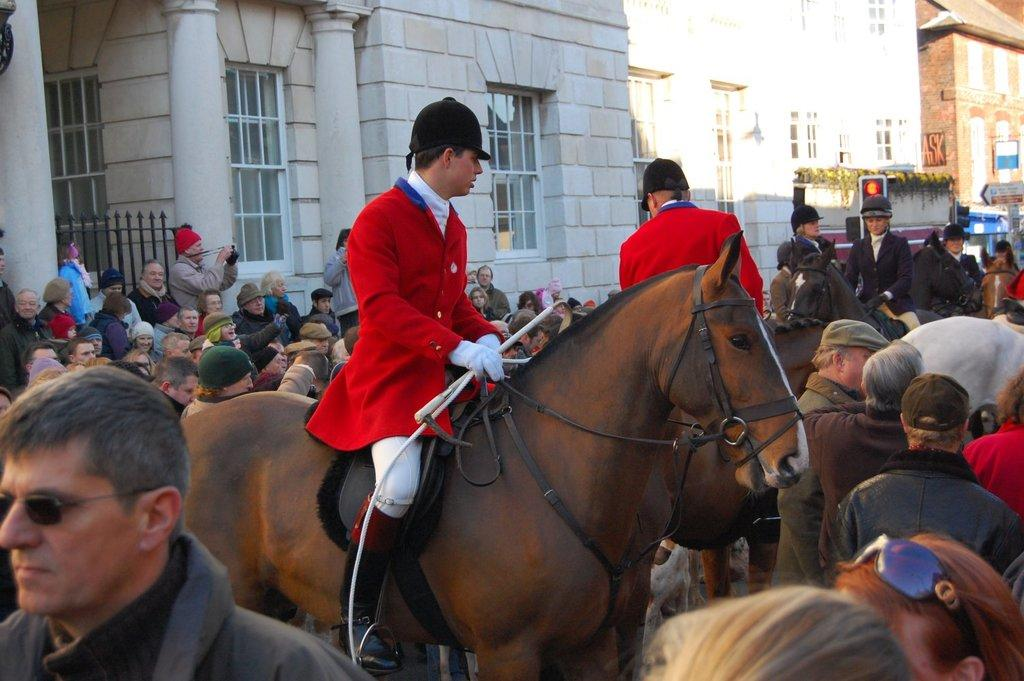What are the people in the image doing? The people in the image are standing on the road. Are there any people riding animals in the image? Yes, some people are sitting on horses. What can be seen in the background of the image? There are buildings in the background. What type of lock is being used to secure the hospital in the image? There is no hospital or lock present in the image. What direction is the zephyr blowing in the image? There is no mention of a zephyr in the image, so it cannot be determined which direction it might be blowing. 